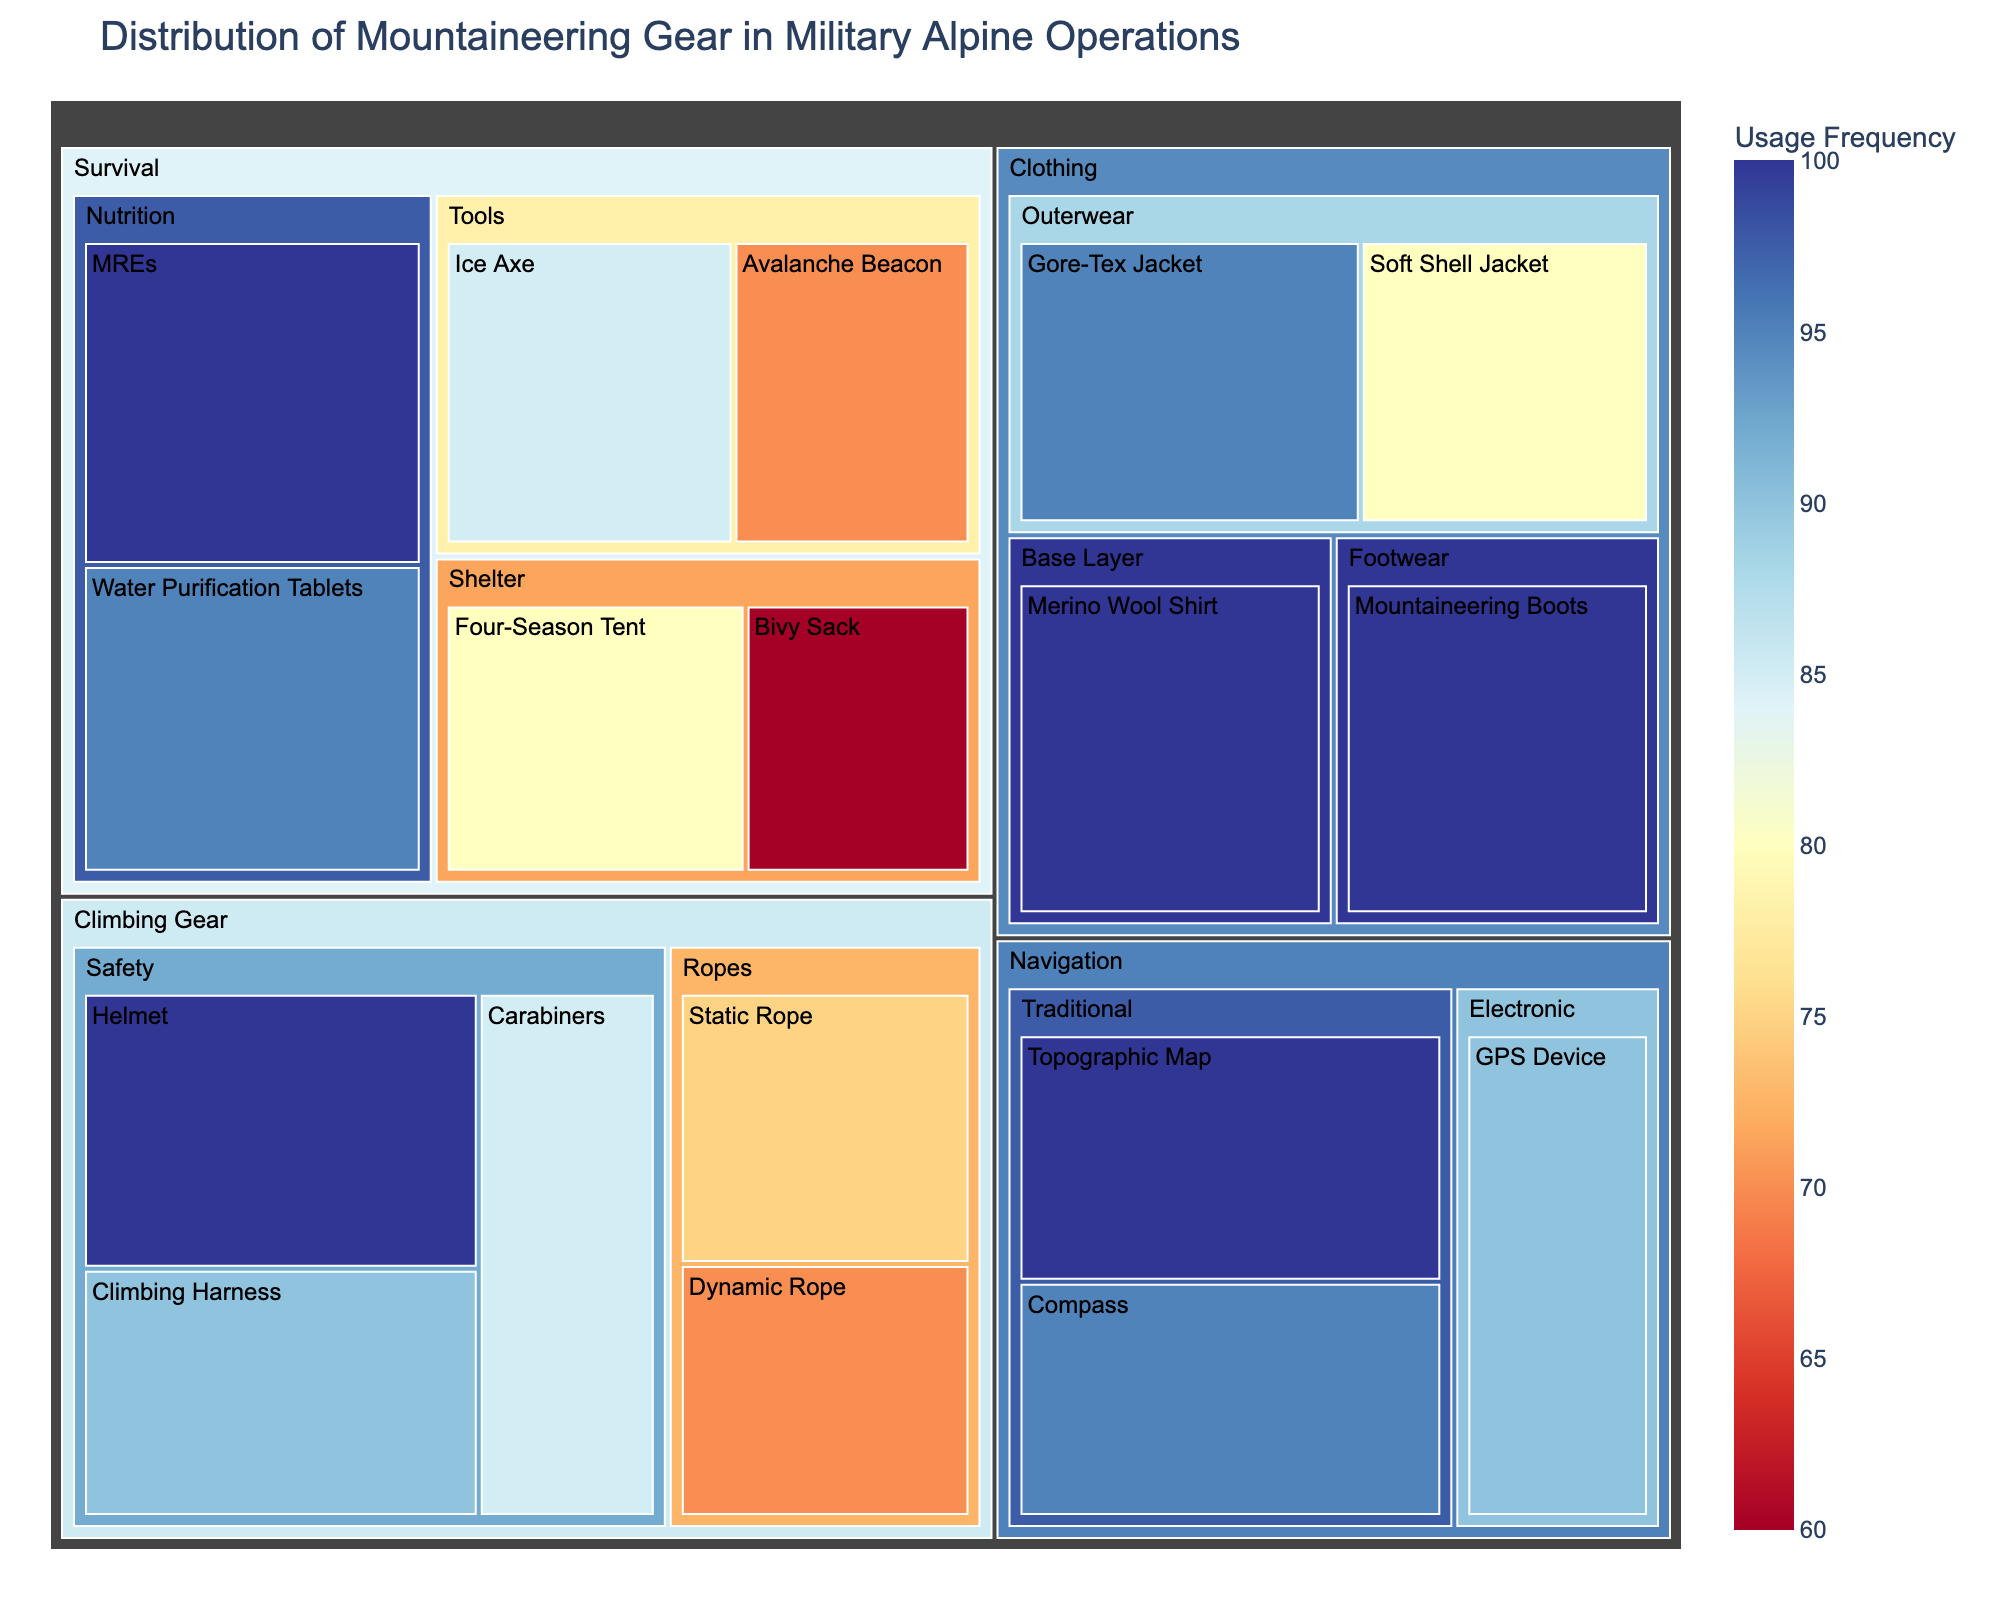What's the title of the figure? The title of the figure is generally positioned at the top. Here it should explicitly specify the context.
Answer: Distribution of Mountaineering Gear in Military Alpine Operations Which item in the "Survival" category has the highest usage frequency? To find this, locate the "Survival" category, then check the bar representing each item within this category. Compare the heights to find the maximum.
Answer: MREs What are the subcategories under the "Navigation" category? Look under the "Navigation" category. The different sections representing subcategories within will be labeled.
Answer: Electronic, Traditional Between "Topographic Map" and "Compass", which traditional navigation tool has a lower usage frequency? Compare the usage frequency values of "Topographic Map" and "Compass" in the figure under the traditional navigation tools.
Answer: Compass What is the combined usage frequency of "Helmet" and "Mountaineering Boots"? Locate the usage frequency values for both items and add them together. Helmet has 100 and Mountaineering Boots also has 100.
Answer: 200 Compare the usage frequency of "Ice Axe" with "Dynamic Rope". Which one is used more? Compare the usage frequencies of "Ice Axe" and "Dynamic Rope". Ice Axe has 85, and Dynamic Rope has 70.
Answer: Ice Axe What percentage of the total usage frequency does "Merino Wool Shirt" account for? First, sum all items' usage frequencies to get the total. The value for "Merino Wool Shirt" is 100. Calculate the percentage by (100 / Total Usage Frequency) * 100.
Answer: 8.7% (assuming total is 1150 from summing all frequencies) How many items have a usage frequency greater than or equal to 95? Look through each item's usage frequency and count how many values meet the criterion of >= 95.
Answer: 7 Is the usage frequency of "Soft Shell Jacket" higher than "Static Rope"? Compare the values for "Soft Shell Jacket" (80) and "Static Rope" (75).
Answer: Yes 